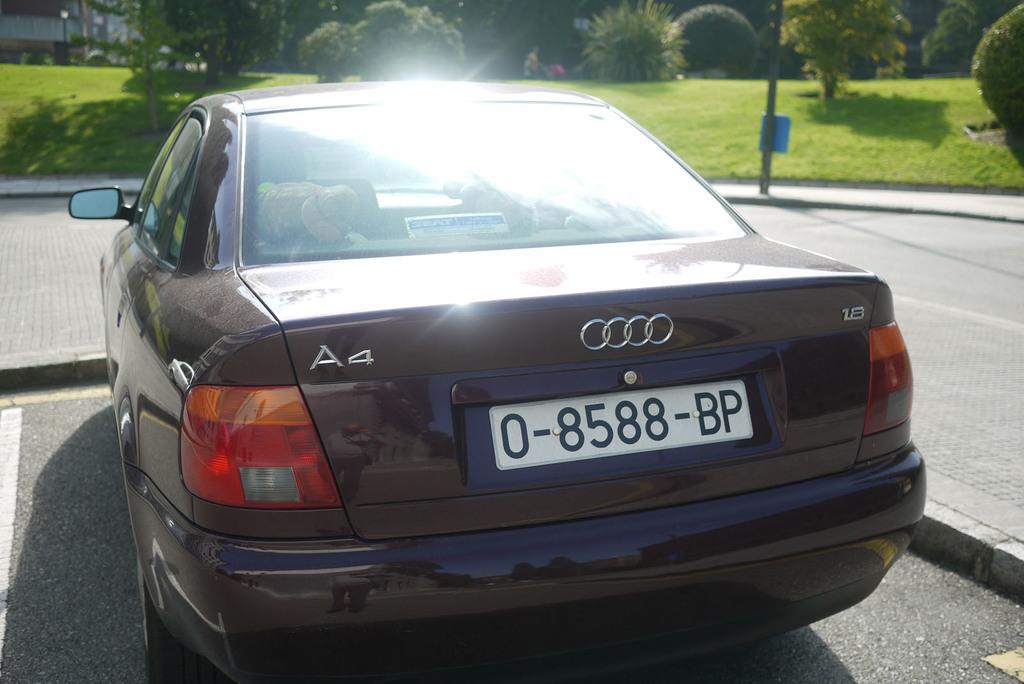What kind of car is this?
Your answer should be very brief. Audi a4. What is the license plate number?
Offer a terse response. 0-8588-bp. 